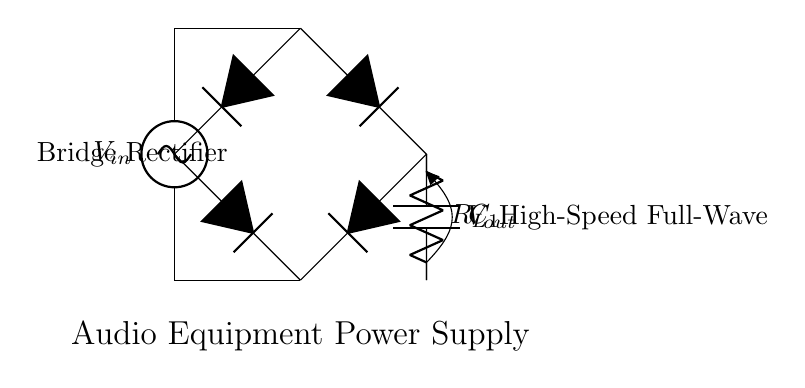What is the input voltage of the circuit? The input voltage is labeled as "V_in" at the AC source in the circuit diagram.
Answer: V_in What does the smoothing capacitor do? The smoothing capacitor, labeled as "C_1," is used to reduce voltage ripple in the output voltage after rectification, providing a more stable DC output.
Answer: Reduces ripple How many diodes are used in the bridge rectifier? There are four diodes used in the bridge rectifier, which are connected in a specific configuration to allow for full-wave rectification of the AC input.
Answer: Four What is the role of the load resistor in the circuit? The load resistor, labeled as "R_L," dissipates the output power from the rectifier, serving as the component that powers the load in this circuit.
Answer: Powers the load Why is this rectifier considered a "full-wave" rectifier? This rectifier is considered full-wave because it uses a bridge configuration to rectify both halves of the AC waveform, allowing current to flow during both the positive and negative cycles.
Answer: Both halves What is the output voltage denoted as in the diagram? The output voltage is labeled as "V_out" and is taken across the load resistor in the circuit after rectification and smoothing.
Answer: V_out What type of equipment is this power supply intended for? The circuit is specifically designed for audio equipment power supplies, enabling efficient power conversion for audio applications.
Answer: Audio equipment 